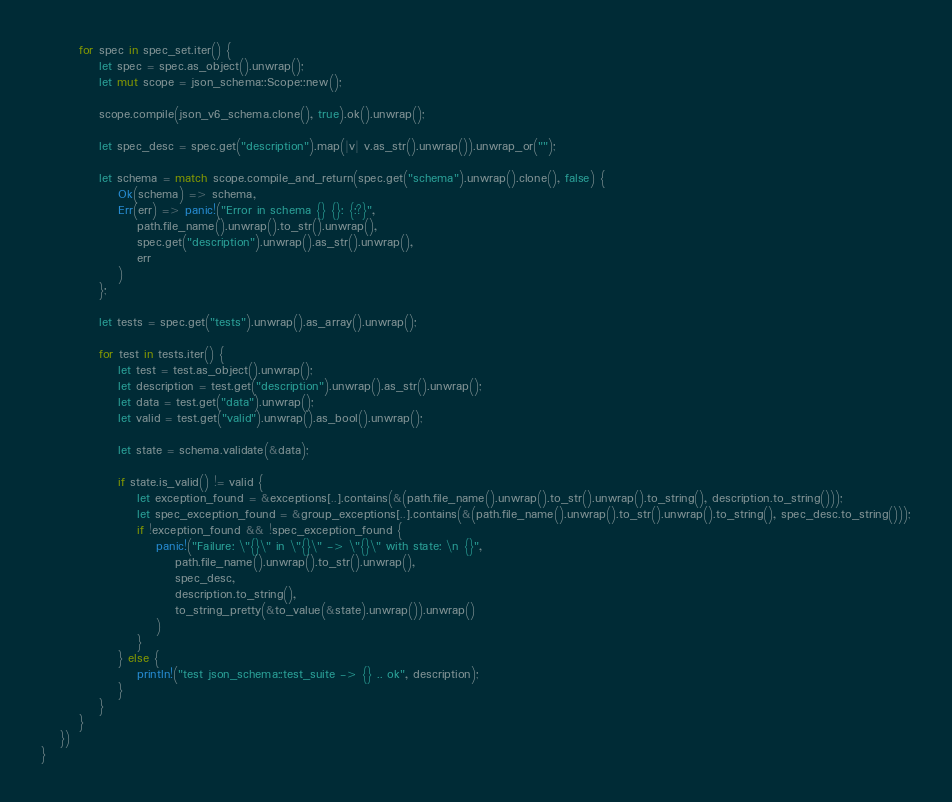Convert code to text. <code><loc_0><loc_0><loc_500><loc_500><_Rust_>
        for spec in spec_set.iter() {
            let spec = spec.as_object().unwrap();
            let mut scope = json_schema::Scope::new();

            scope.compile(json_v6_schema.clone(), true).ok().unwrap();

            let spec_desc = spec.get("description").map(|v| v.as_str().unwrap()).unwrap_or("");

            let schema = match scope.compile_and_return(spec.get("schema").unwrap().clone(), false) {
                Ok(schema) => schema,
                Err(err) => panic!("Error in schema {} {}: {:?}",
                    path.file_name().unwrap().to_str().unwrap(),
                    spec.get("description").unwrap().as_str().unwrap(),
                    err
                )
            };

            let tests = spec.get("tests").unwrap().as_array().unwrap();

            for test in tests.iter() {
                let test = test.as_object().unwrap();
                let description = test.get("description").unwrap().as_str().unwrap();
                let data = test.get("data").unwrap();
                let valid = test.get("valid").unwrap().as_bool().unwrap();

                let state = schema.validate(&data);

                if state.is_valid() != valid {
                    let exception_found = &exceptions[..].contains(&(path.file_name().unwrap().to_str().unwrap().to_string(), description.to_string()));
                    let spec_exception_found = &group_exceptions[..].contains(&(path.file_name().unwrap().to_str().unwrap().to_string(), spec_desc.to_string()));
                    if !exception_found && !spec_exception_found {
                        panic!("Failure: \"{}\" in \"{}\" -> \"{}\" with state: \n {}",
                            path.file_name().unwrap().to_str().unwrap(),
                            spec_desc,
                            description.to_string(),
                            to_string_pretty(&to_value(&state).unwrap()).unwrap()
                        )
                    }
                } else {
                    println!("test json_schema::test_suite -> {} .. ok", description);
                }
            }
        }
    })
}
</code> 